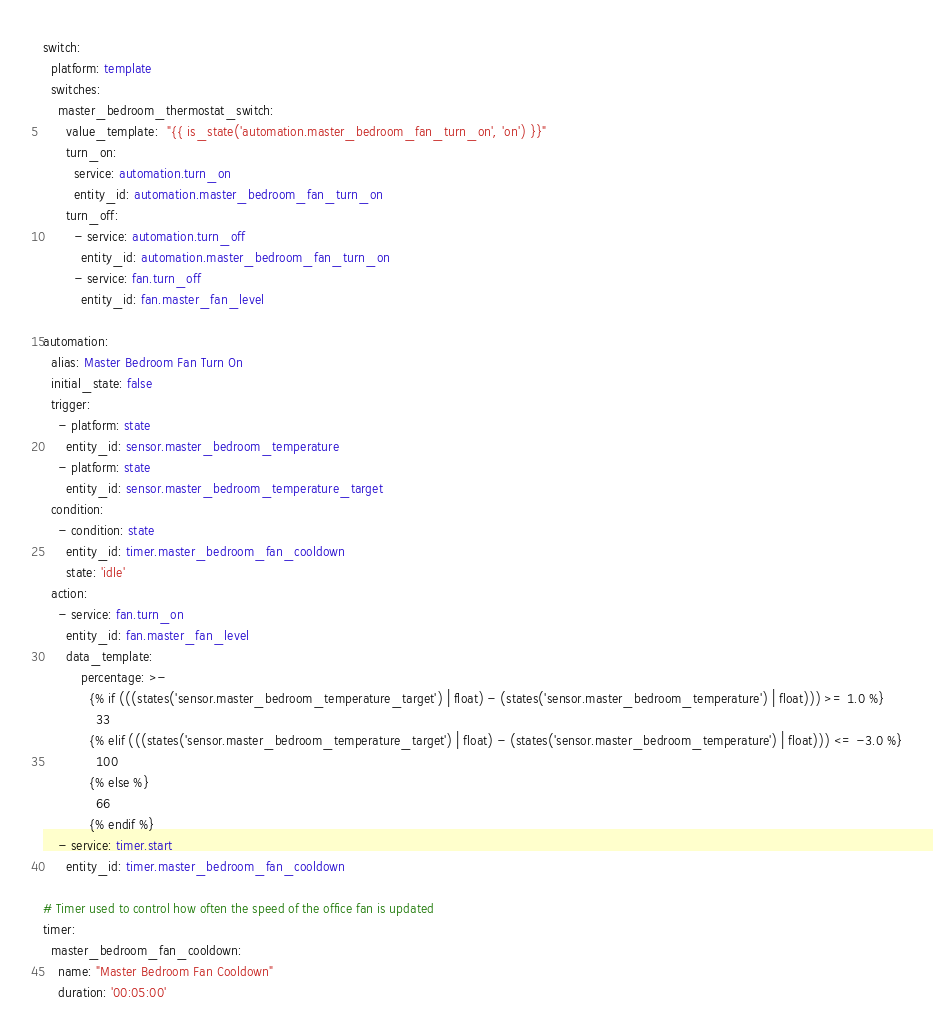<code> <loc_0><loc_0><loc_500><loc_500><_YAML_>switch: 
  platform: template
  switches:
    master_bedroom_thermostat_switch:
      value_template:  "{{ is_state('automation.master_bedroom_fan_turn_on', 'on') }}"
      turn_on:
        service: automation.turn_on
        entity_id: automation.master_bedroom_fan_turn_on
      turn_off:
        - service: automation.turn_off
          entity_id: automation.master_bedroom_fan_turn_on
        - service: fan.turn_off
          entity_id: fan.master_fan_level

automation:
  alias: Master Bedroom Fan Turn On
  initial_state: false
  trigger:
    - platform: state
      entity_id: sensor.master_bedroom_temperature
    - platform: state
      entity_id: sensor.master_bedroom_temperature_target
  condition:
    - condition: state
      entity_id: timer.master_bedroom_fan_cooldown
      state: 'idle'
  action:
    - service: fan.turn_on
      entity_id: fan.master_fan_level
      data_template:
          percentage: >-
            {% if (((states('sensor.master_bedroom_temperature_target') | float) - (states('sensor.master_bedroom_temperature') | float))) >= 1.0 %}
              33
            {% elif (((states('sensor.master_bedroom_temperature_target') | float) - (states('sensor.master_bedroom_temperature') | float))) <= -3.0 %}
              100
            {% else %}
              66
            {% endif %}
    - service: timer.start
      entity_id: timer.master_bedroom_fan_cooldown

# Timer used to control how often the speed of the office fan is updated
timer:
  master_bedroom_fan_cooldown:
    name: "Master Bedroom Fan Cooldown"
    duration: '00:05:00'
</code> 